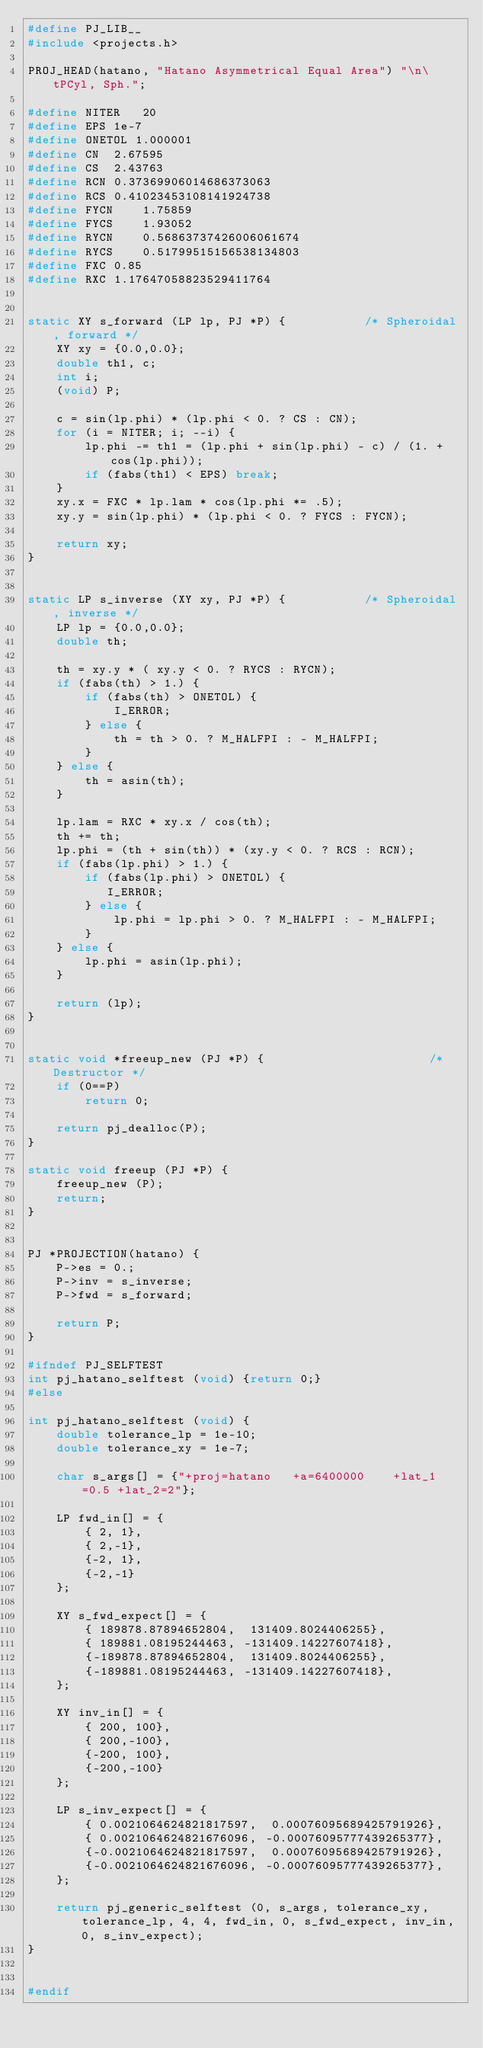<code> <loc_0><loc_0><loc_500><loc_500><_C_>#define PJ_LIB__
#include <projects.h>

PROJ_HEAD(hatano, "Hatano Asymmetrical Equal Area") "\n\tPCyl, Sph.";

#define NITER   20
#define EPS 1e-7
#define ONETOL 1.000001
#define CN  2.67595
#define CS  2.43763
#define RCN 0.37369906014686373063
#define RCS 0.41023453108141924738
#define FYCN    1.75859
#define FYCS    1.93052
#define RYCN    0.56863737426006061674
#define RYCS    0.51799515156538134803
#define FXC 0.85
#define RXC 1.17647058823529411764


static XY s_forward (LP lp, PJ *P) {           /* Spheroidal, forward */
    XY xy = {0.0,0.0};
    double th1, c;
    int i;
    (void) P;

    c = sin(lp.phi) * (lp.phi < 0. ? CS : CN);
    for (i = NITER; i; --i) {
        lp.phi -= th1 = (lp.phi + sin(lp.phi) - c) / (1. + cos(lp.phi));
        if (fabs(th1) < EPS) break;
    }
    xy.x = FXC * lp.lam * cos(lp.phi *= .5);
    xy.y = sin(lp.phi) * (lp.phi < 0. ? FYCS : FYCN);

    return xy;
}


static LP s_inverse (XY xy, PJ *P) {           /* Spheroidal, inverse */
    LP lp = {0.0,0.0};
    double th;

    th = xy.y * ( xy.y < 0. ? RYCS : RYCN);
    if (fabs(th) > 1.) {
        if (fabs(th) > ONETOL) {
            I_ERROR;
        } else {
            th = th > 0. ? M_HALFPI : - M_HALFPI;
        }
    } else {
        th = asin(th);
    }

    lp.lam = RXC * xy.x / cos(th);
    th += th;
    lp.phi = (th + sin(th)) * (xy.y < 0. ? RCS : RCN);
    if (fabs(lp.phi) > 1.) {
        if (fabs(lp.phi) > ONETOL) {
           I_ERROR;
        } else {
            lp.phi = lp.phi > 0. ? M_HALFPI : - M_HALFPI;
        }
    } else {
        lp.phi = asin(lp.phi);
    }

    return (lp);
}


static void *freeup_new (PJ *P) {                       /* Destructor */
    if (0==P)
        return 0;

    return pj_dealloc(P);
}

static void freeup (PJ *P) {
    freeup_new (P);
    return;
}


PJ *PROJECTION(hatano) {
    P->es = 0.;
    P->inv = s_inverse;
    P->fwd = s_forward;

    return P;
}

#ifndef PJ_SELFTEST
int pj_hatano_selftest (void) {return 0;}
#else

int pj_hatano_selftest (void) {
    double tolerance_lp = 1e-10;
    double tolerance_xy = 1e-7;

    char s_args[] = {"+proj=hatano   +a=6400000    +lat_1=0.5 +lat_2=2"};

    LP fwd_in[] = {
        { 2, 1},
        { 2,-1},
        {-2, 1},
        {-2,-1}
    };

    XY s_fwd_expect[] = {
        { 189878.87894652804,  131409.8024406255},
        { 189881.08195244463, -131409.14227607418},
        {-189878.87894652804,  131409.8024406255},
        {-189881.08195244463, -131409.14227607418},
    };

    XY inv_in[] = {
        { 200, 100},
        { 200,-100},
        {-200, 100},
        {-200,-100}
    };

    LP s_inv_expect[] = {
        { 0.0021064624821817597,  0.00076095689425791926},
        { 0.0021064624821676096, -0.00076095777439265377},
        {-0.0021064624821817597,  0.00076095689425791926},
        {-0.0021064624821676096, -0.00076095777439265377},
    };

    return pj_generic_selftest (0, s_args, tolerance_xy, tolerance_lp, 4, 4, fwd_in, 0, s_fwd_expect, inv_in, 0, s_inv_expect);
}


#endif
</code> 